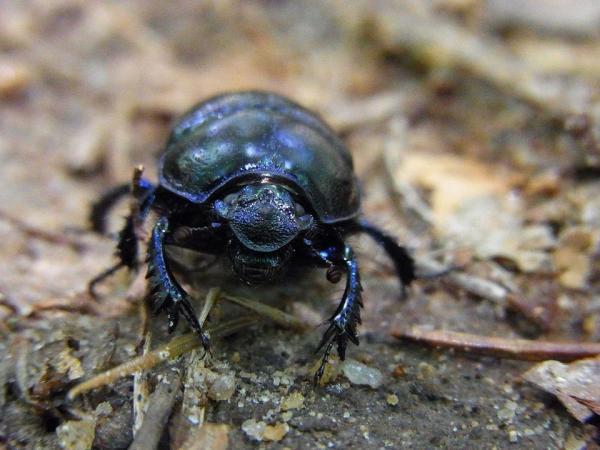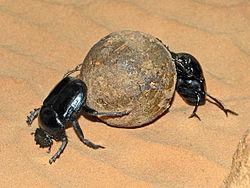The first image is the image on the left, the second image is the image on the right. Given the left and right images, does the statement "There are exactly three dung beetles." hold true? Answer yes or no. Yes. The first image is the image on the left, the second image is the image on the right. Considering the images on both sides, is "there is one beetle with dung in the left side image" valid? Answer yes or no. No. 